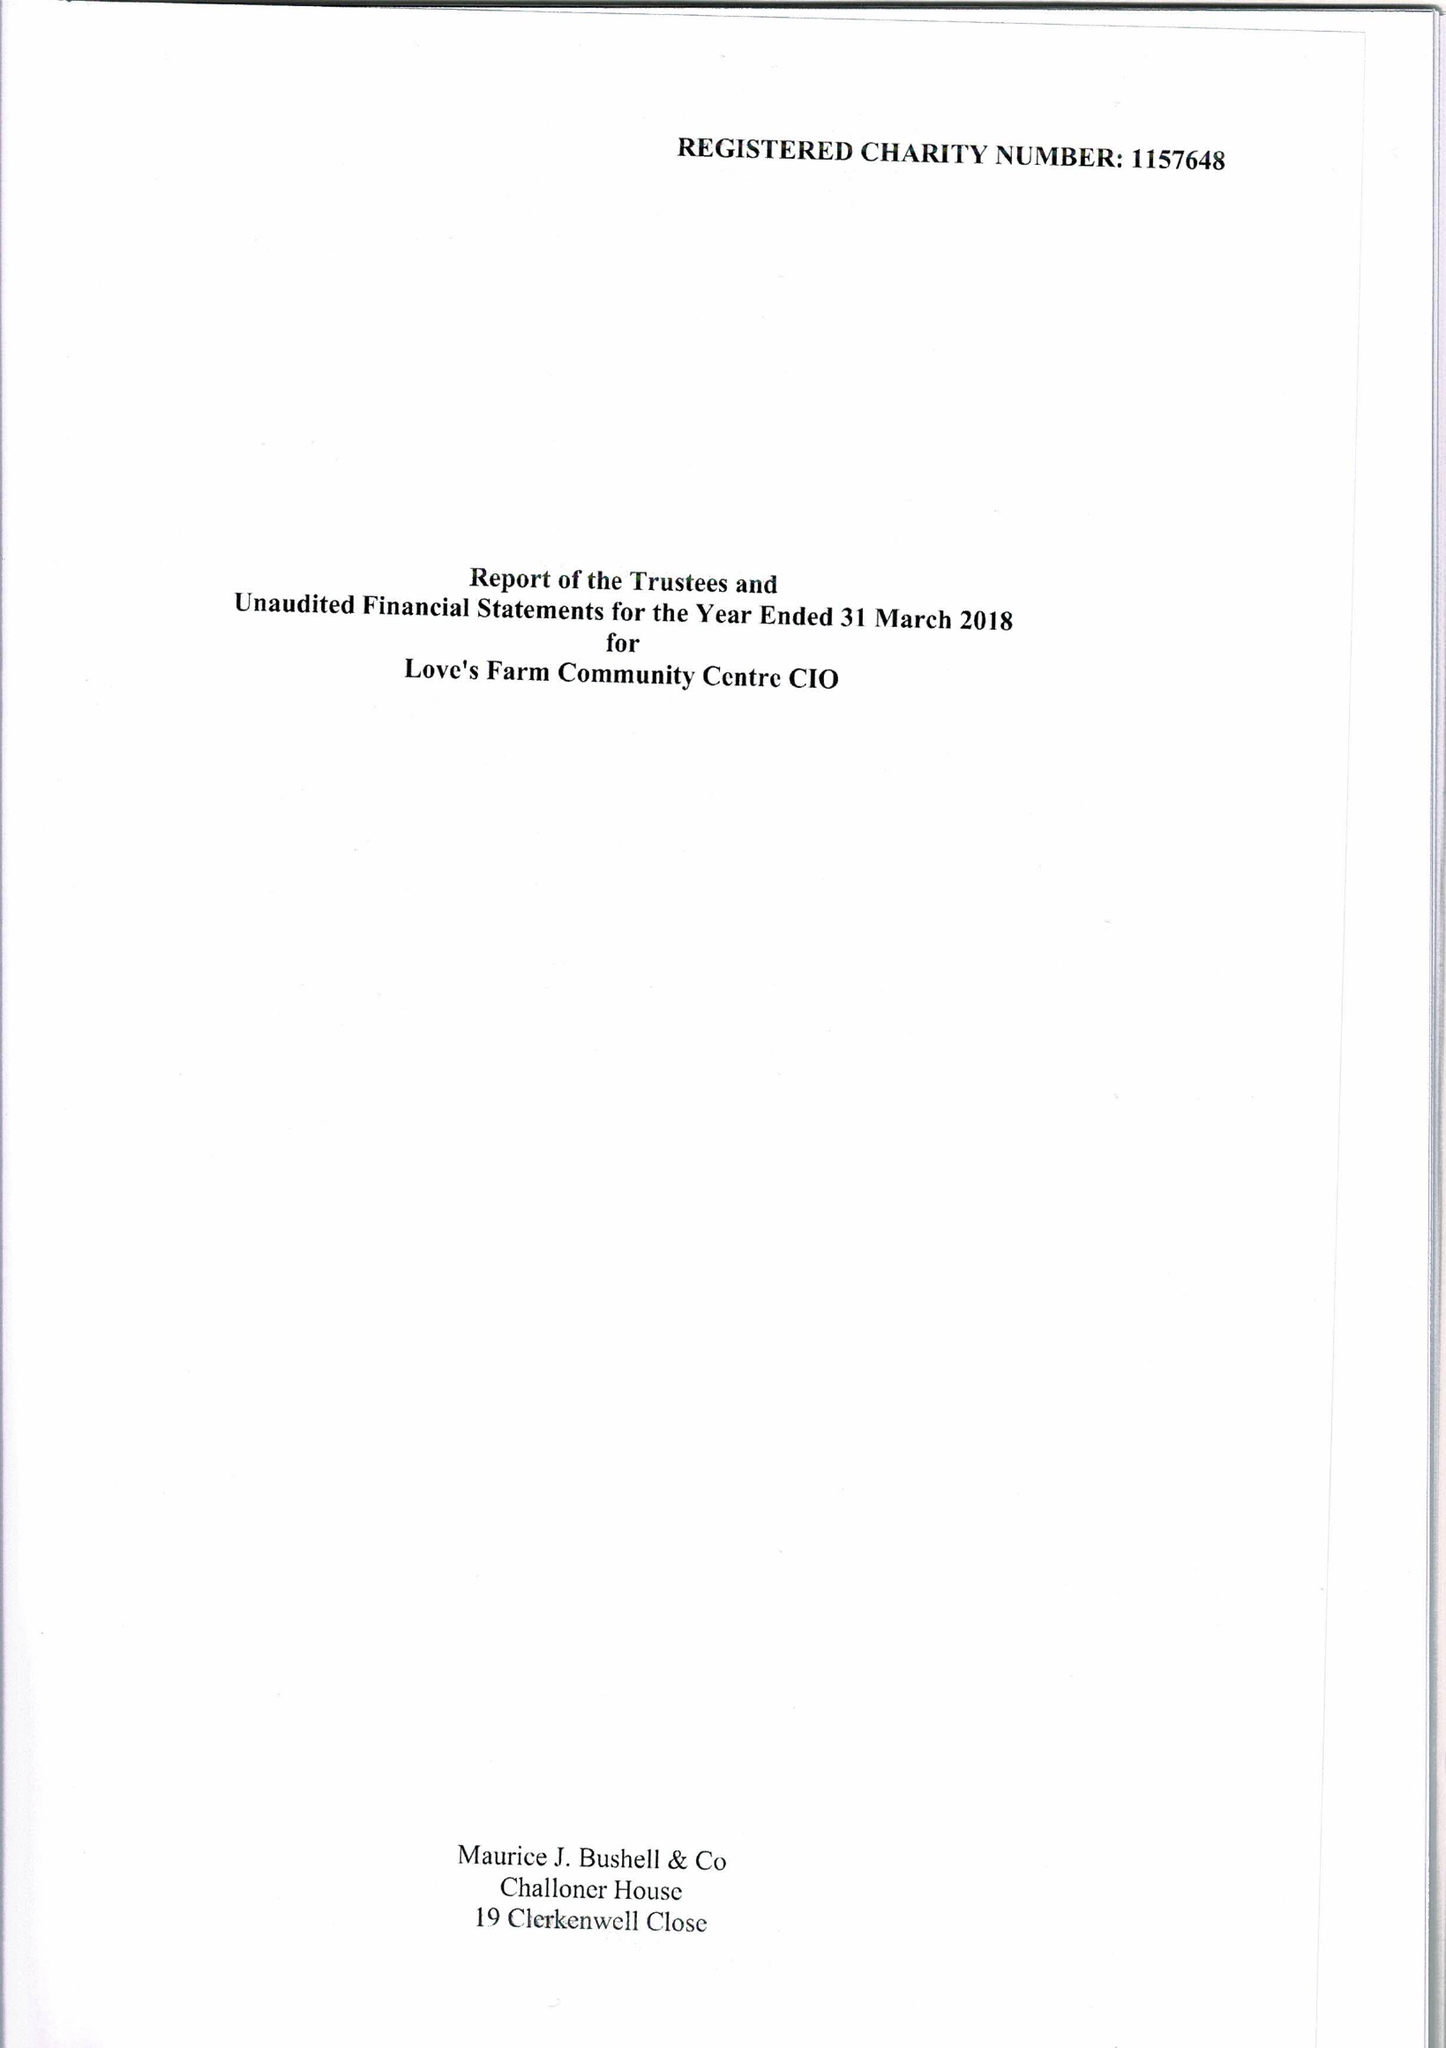What is the value for the address__postcode?
Answer the question using a single word or phrase. PE19 6SL 